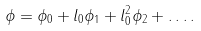<formula> <loc_0><loc_0><loc_500><loc_500>\phi = \phi _ { 0 } + l _ { 0 } \phi _ { 1 } + l _ { 0 } ^ { 2 } \phi _ { 2 } + \dots .</formula> 